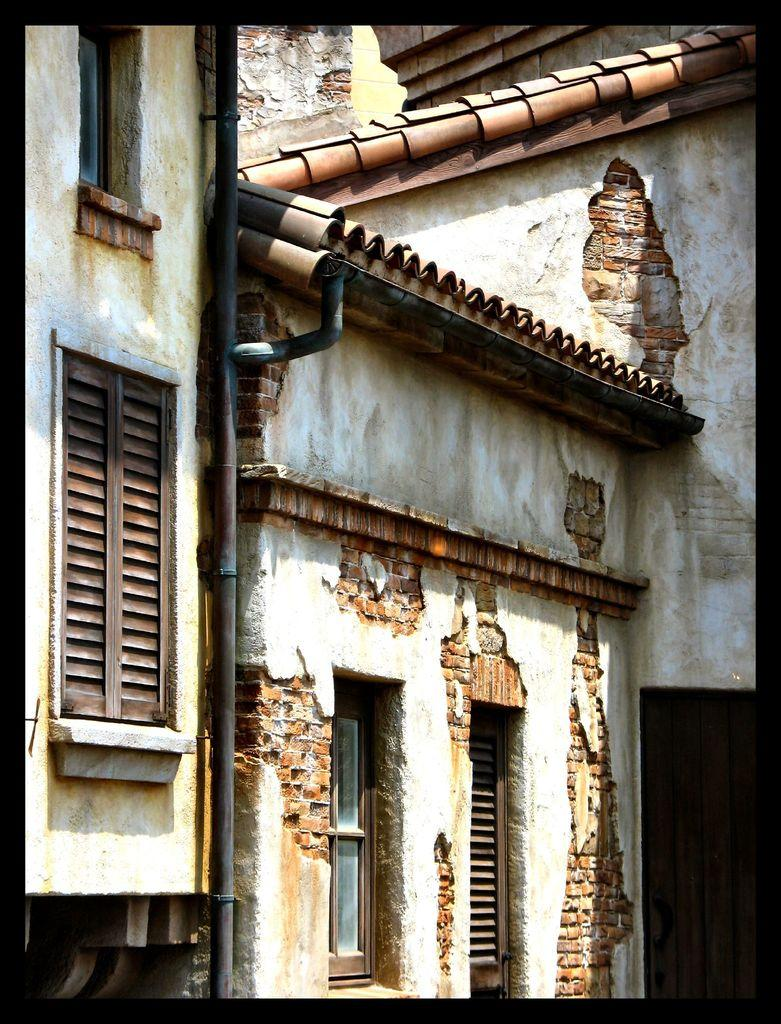What type of structure is present in the image? There is a building in the image. What feature can be seen on the building? The building has windows. What material is used for the roof of the building? The roof of the building is made up of tiles. What type of feast is being prepared in the building? There is no indication of a feast or any food preparation in the image; it only shows a building with windows and a tiled roof. 